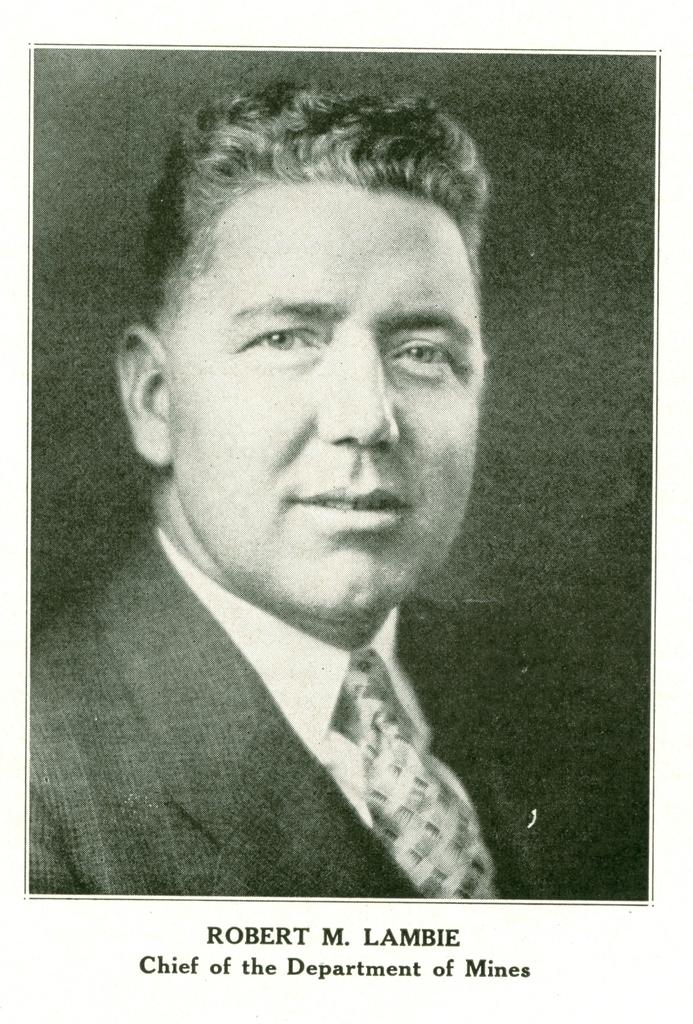Who is in the picture? There is a man in the picture. What is the man wearing? The man is wearing a blazer and a tie. What is the man's facial expression? The man is smiling. What can be found at the bottom of the picture? There is some text at the bottom of the picture. What type of cord is being used by the man in the picture? There is no cord visible in the image; the man is wearing a blazer and a tie, but no cord is mentioned in the facts. 